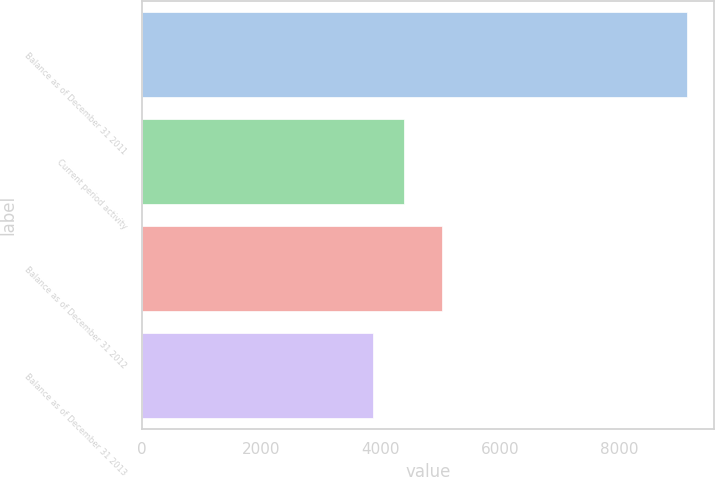Convert chart to OTSL. <chart><loc_0><loc_0><loc_500><loc_500><bar_chart><fcel>Balance as of December 31 2011<fcel>Current period activity<fcel>Balance as of December 31 2012<fcel>Balance as of December 31 2013<nl><fcel>9139<fcel>4404.1<fcel>5033<fcel>3878<nl></chart> 